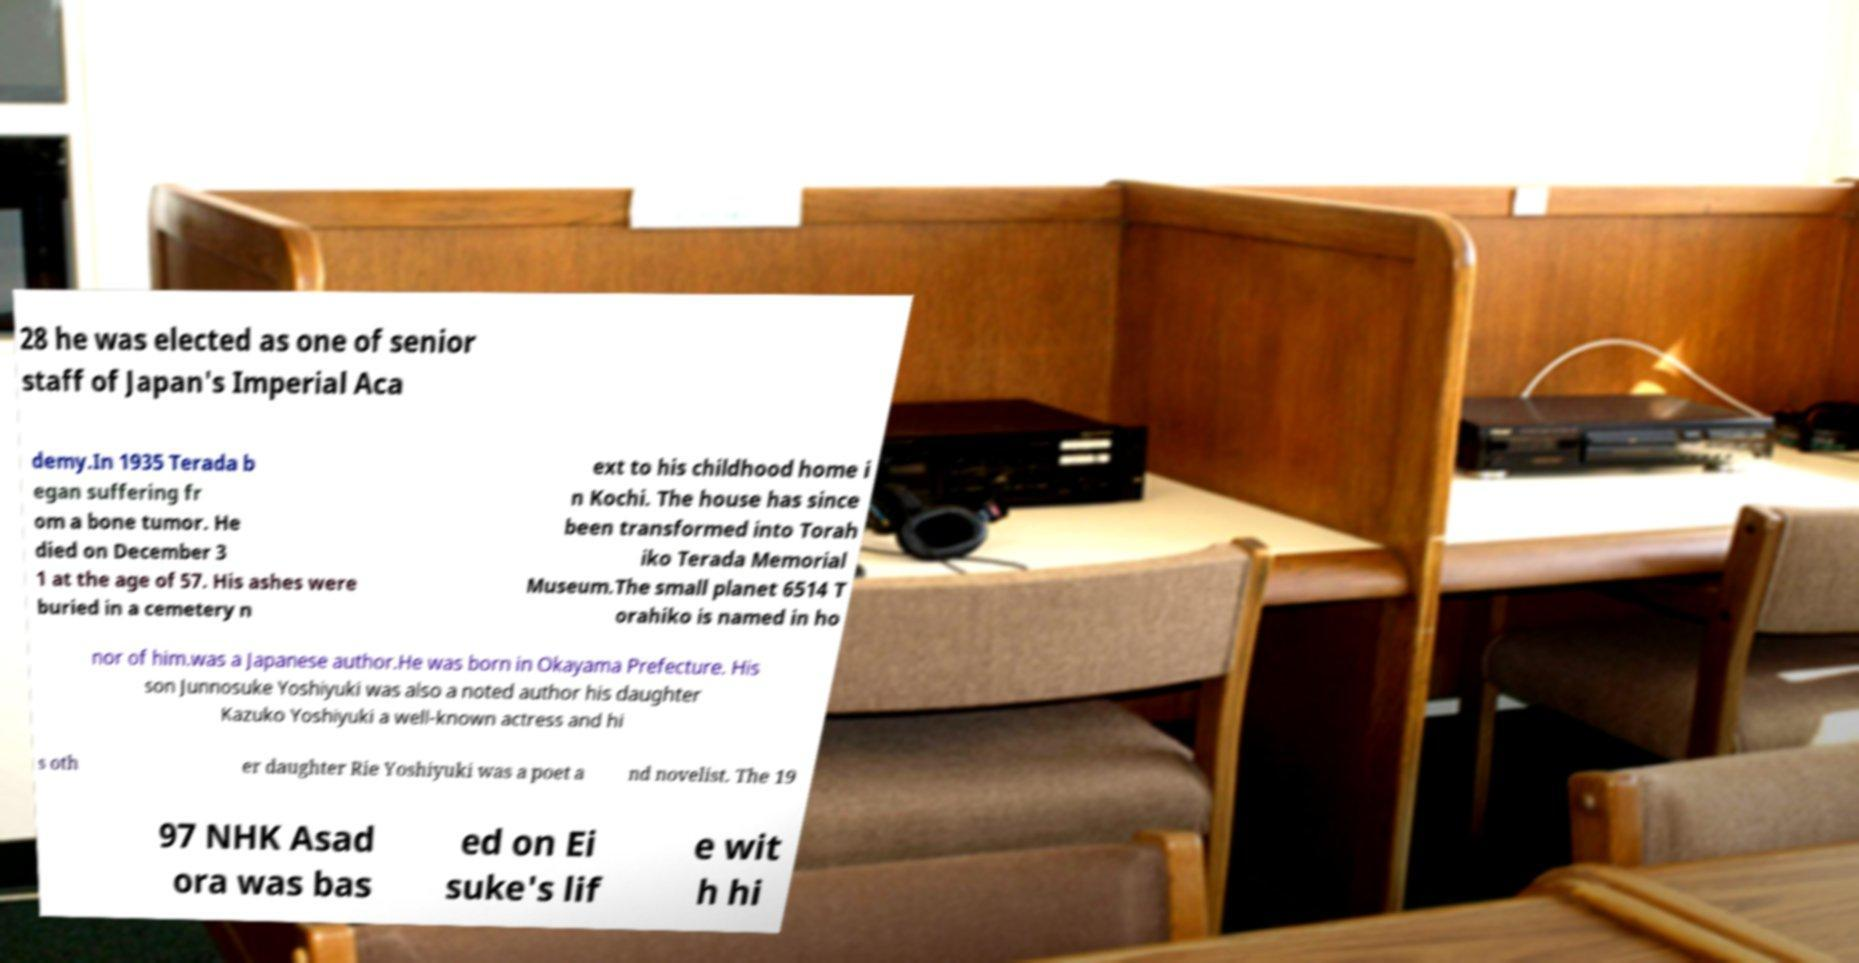Could you assist in decoding the text presented in this image and type it out clearly? 28 he was elected as one of senior staff of Japan's Imperial Aca demy.In 1935 Terada b egan suffering fr om a bone tumor. He died on December 3 1 at the age of 57. His ashes were buried in a cemetery n ext to his childhood home i n Kochi. The house has since been transformed into Torah iko Terada Memorial Museum.The small planet 6514 T orahiko is named in ho nor of him.was a Japanese author.He was born in Okayama Prefecture. His son Junnosuke Yoshiyuki was also a noted author his daughter Kazuko Yoshiyuki a well-known actress and hi s oth er daughter Rie Yoshiyuki was a poet a nd novelist. The 19 97 NHK Asad ora was bas ed on Ei suke's lif e wit h hi 